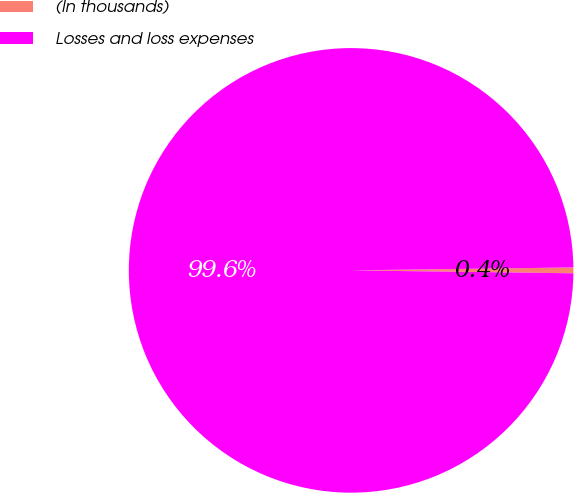<chart> <loc_0><loc_0><loc_500><loc_500><pie_chart><fcel>(In thousands)<fcel>Losses and loss expenses<nl><fcel>0.42%<fcel>99.58%<nl></chart> 